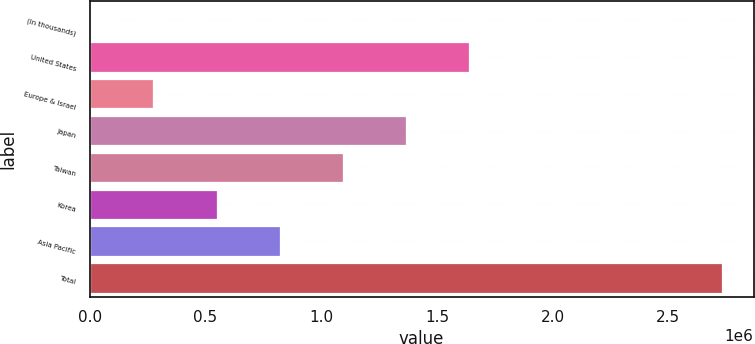Convert chart. <chart><loc_0><loc_0><loc_500><loc_500><bar_chart><fcel>(In thousands)<fcel>United States<fcel>Europe & Israel<fcel>Japan<fcel>Taiwan<fcel>Korea<fcel>Asia Pacific<fcel>Total<nl><fcel>2007<fcel>1.63954e+06<fcel>274929<fcel>1.36662e+06<fcel>1.0937e+06<fcel>547851<fcel>820774<fcel>2.73123e+06<nl></chart> 